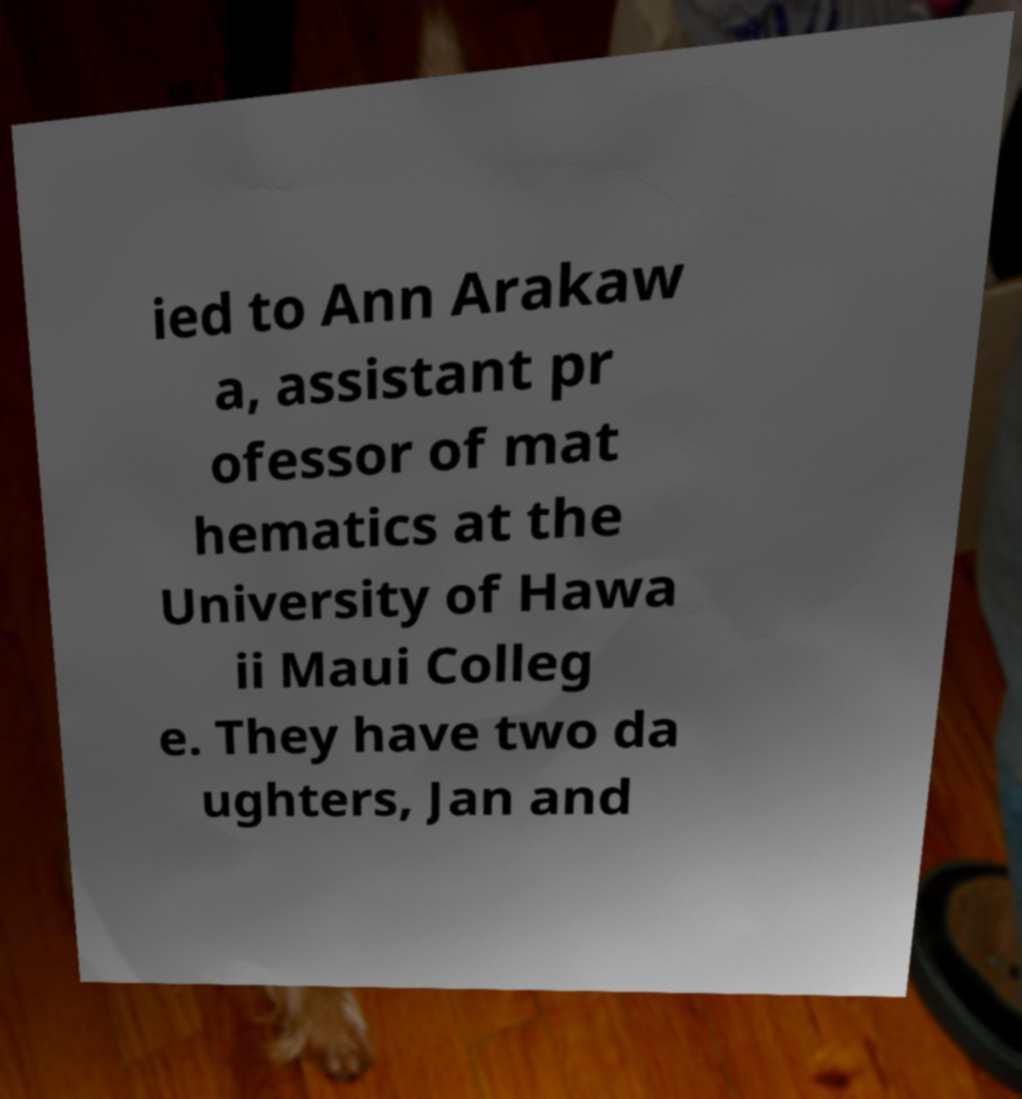Please read and relay the text visible in this image. What does it say? ied to Ann Arakaw a, assistant pr ofessor of mat hematics at the University of Hawa ii Maui Colleg e. They have two da ughters, Jan and 